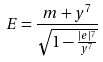<formula> <loc_0><loc_0><loc_500><loc_500>E = \frac { m + y ^ { 7 } } { \sqrt { 1 - \frac { | e | ^ { 7 } } { y ^ { 7 } } } }</formula> 